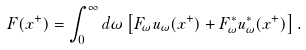Convert formula to latex. <formula><loc_0><loc_0><loc_500><loc_500>F ( x ^ { + } ) = \int _ { 0 } ^ { \infty } d \omega \left [ F _ { \omega } u _ { \omega } ( x ^ { + } ) + F _ { \omega } ^ { \ast } u _ { \omega } ^ { \ast } ( x ^ { + } ) \right ] .</formula> 